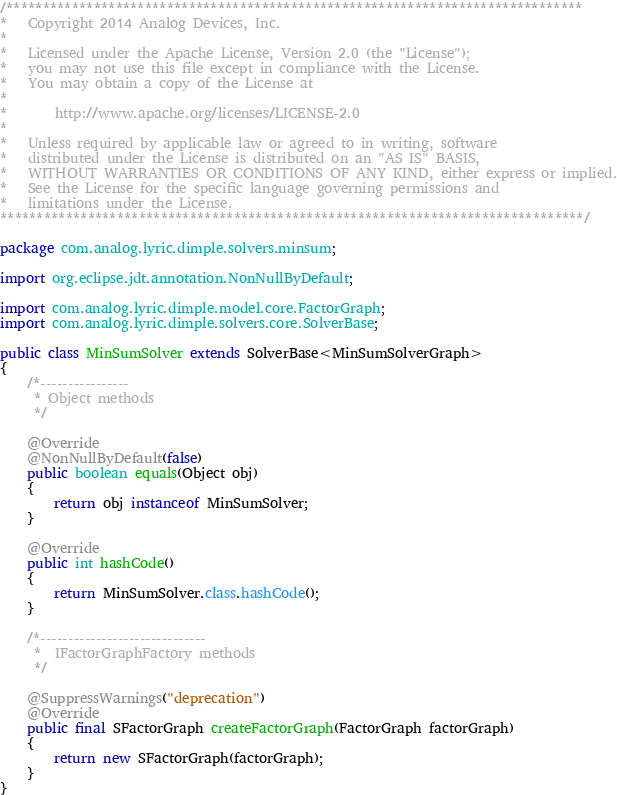Convert code to text. <code><loc_0><loc_0><loc_500><loc_500><_Java_>/*******************************************************************************
*   Copyright 2014 Analog Devices, Inc.
*
*   Licensed under the Apache License, Version 2.0 (the "License");
*   you may not use this file except in compliance with the License.
*   You may obtain a copy of the License at
*
*       http://www.apache.org/licenses/LICENSE-2.0
*
*   Unless required by applicable law or agreed to in writing, software
*   distributed under the License is distributed on an "AS IS" BASIS,
*   WITHOUT WARRANTIES OR CONDITIONS OF ANY KIND, either express or implied.
*   See the License for the specific language governing permissions and
*   limitations under the License.
********************************************************************************/

package com.analog.lyric.dimple.solvers.minsum;

import org.eclipse.jdt.annotation.NonNullByDefault;

import com.analog.lyric.dimple.model.core.FactorGraph;
import com.analog.lyric.dimple.solvers.core.SolverBase;

public class MinSumSolver extends SolverBase<MinSumSolverGraph>
{
	/*----------------
	 * Object methods
	 */
	
	@Override
	@NonNullByDefault(false)
	public boolean equals(Object obj)
	{
		return obj instanceof MinSumSolver;
	}
	
	@Override
	public int hashCode()
	{
		return MinSumSolver.class.hashCode();
	}
	
	/*------------------------------
	 *  IFactorGraphFactory methods
	 */
	
	@SuppressWarnings("deprecation")
	@Override
	public final SFactorGraph createFactorGraph(FactorGraph factorGraph)
	{
		return new SFactorGraph(factorGraph);
	}
}
</code> 